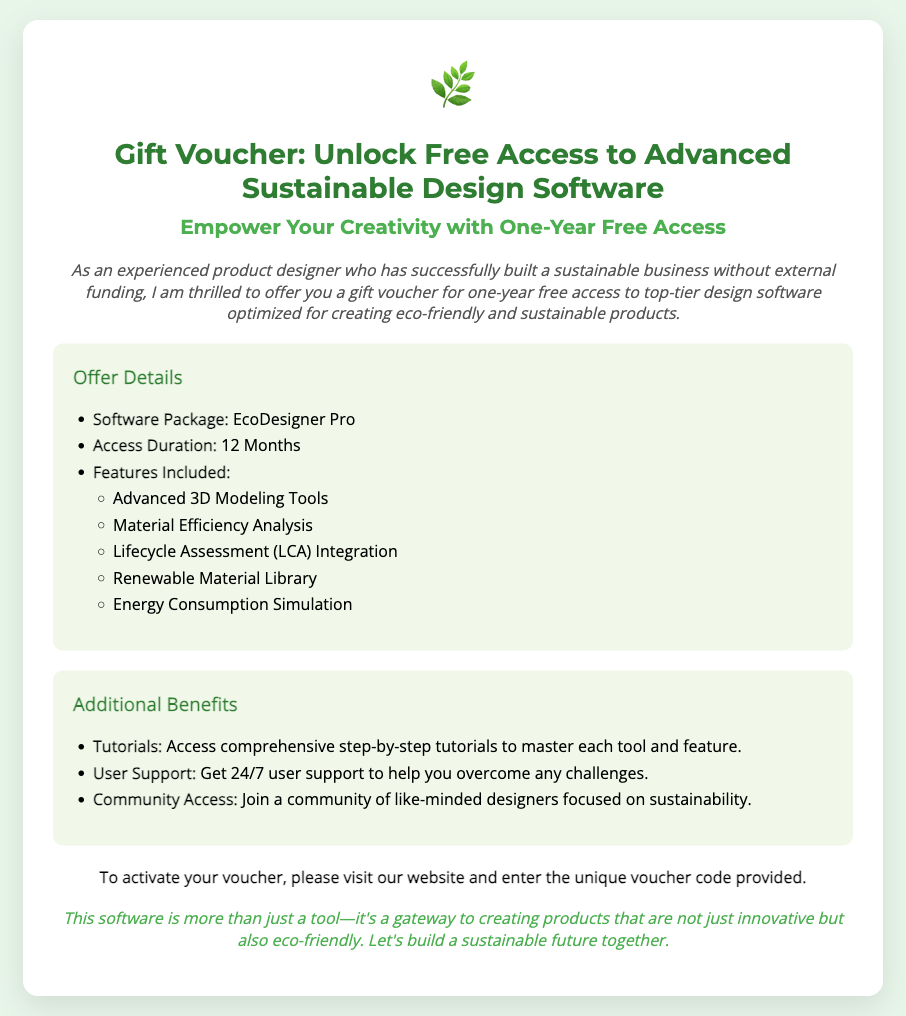What is the name of the software provided? The document states that the software package included is EcoDesigner Pro.
Answer: EcoDesigner Pro How long is the access duration for the voucher? The document specifies that the access duration is 12 months.
Answer: 12 Months What feature helps in analyzing material efficiency? In the offer details, the feature listed for analyzing material efficiency is Material Efficiency Analysis.
Answer: Material Efficiency Analysis What type of community access is offered? The document mentions that users can join a community of like-minded designers focused on sustainability.
Answer: Community of like-minded designers What should users do to activate the voucher? The requirements section states that to activate the voucher, users need to visit the website and enter the unique voucher code provided.
Answer: Visit our website and enter the unique voucher code What is the main purpose of the software according to the closing note? The closing note highlights that the software is a gateway to creating innovative and eco-friendly products.
Answer: Creating innovative and eco-friendly products What kind of support will be available to users? The document specifies that users will receive 24/7 user support for any challenges they face.
Answer: 24/7 user support What is the eco-icon used in the document? The document features a nature-related emoji representing the eco-friendly theme, specifically a plant emoji.
Answer: 🌿 